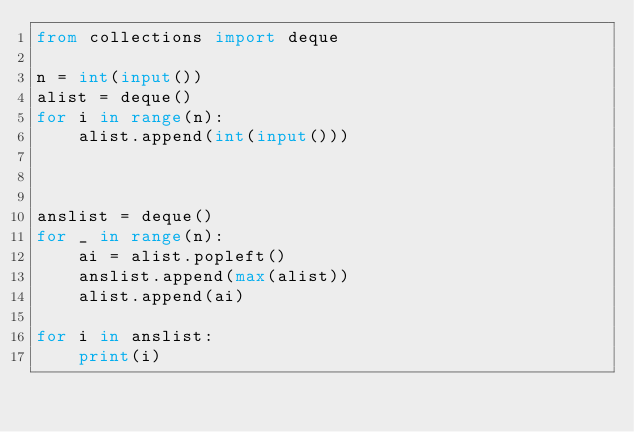<code> <loc_0><loc_0><loc_500><loc_500><_Python_>from collections import deque

n = int(input())
alist = deque()
for i in range(n):
    alist.append(int(input()))



anslist = deque()
for _ in range(n):
    ai = alist.popleft()
    anslist.append(max(alist))
    alist.append(ai)

for i in anslist:
    print(i)
    
    </code> 